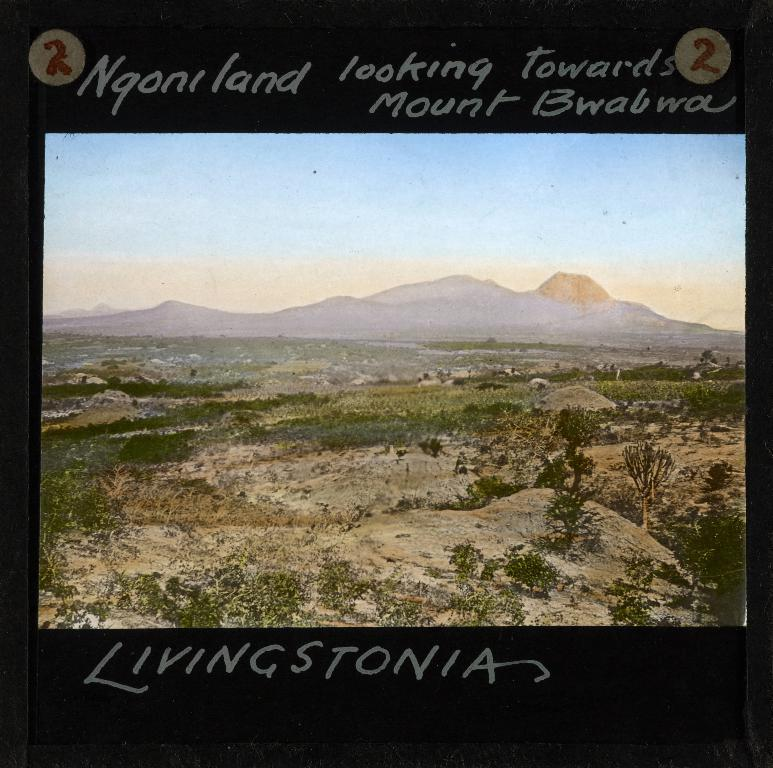<image>
Offer a succinct explanation of the picture presented. Mount Bwabwa is the direction that is being faced. 